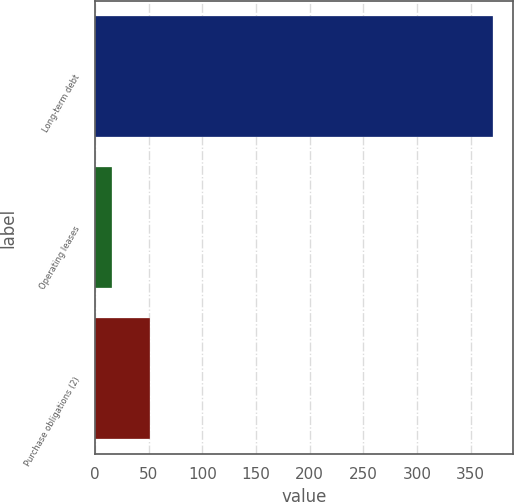Convert chart. <chart><loc_0><loc_0><loc_500><loc_500><bar_chart><fcel>Long-term debt<fcel>Operating leases<fcel>Purchase obligations (2)<nl><fcel>371<fcel>16<fcel>51.5<nl></chart> 